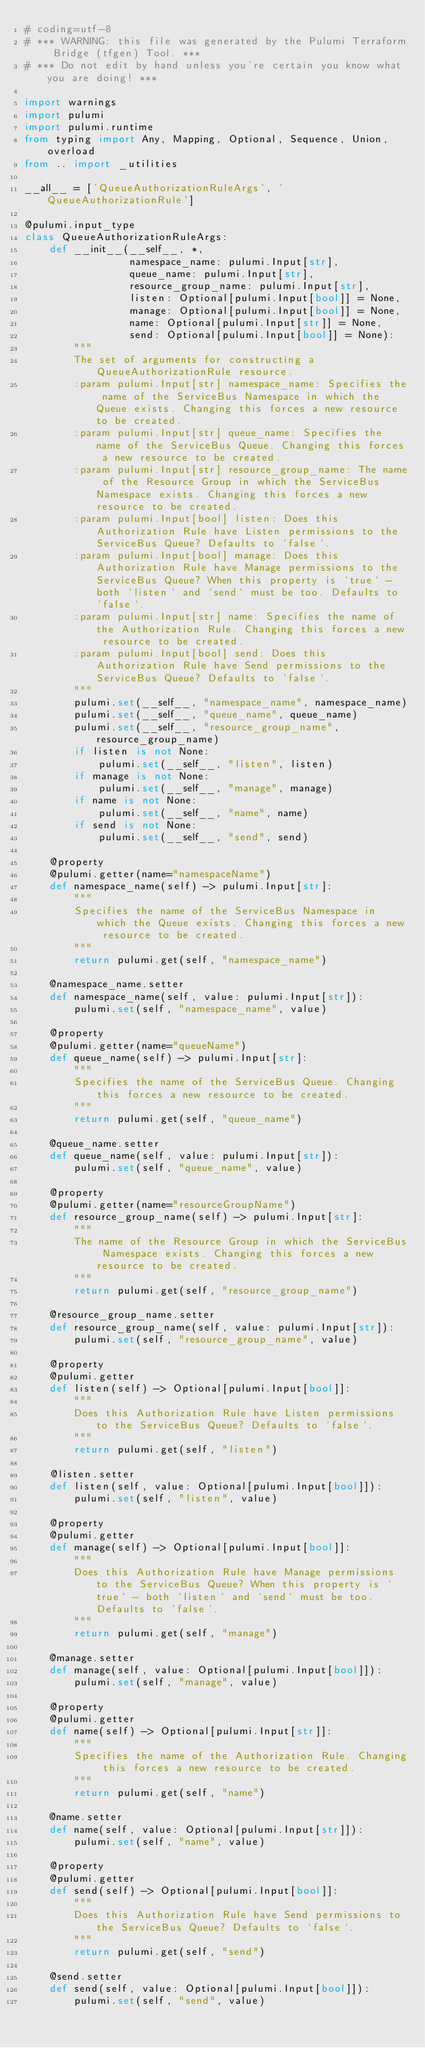Convert code to text. <code><loc_0><loc_0><loc_500><loc_500><_Python_># coding=utf-8
# *** WARNING: this file was generated by the Pulumi Terraform Bridge (tfgen) Tool. ***
# *** Do not edit by hand unless you're certain you know what you are doing! ***

import warnings
import pulumi
import pulumi.runtime
from typing import Any, Mapping, Optional, Sequence, Union, overload
from .. import _utilities

__all__ = ['QueueAuthorizationRuleArgs', 'QueueAuthorizationRule']

@pulumi.input_type
class QueueAuthorizationRuleArgs:
    def __init__(__self__, *,
                 namespace_name: pulumi.Input[str],
                 queue_name: pulumi.Input[str],
                 resource_group_name: pulumi.Input[str],
                 listen: Optional[pulumi.Input[bool]] = None,
                 manage: Optional[pulumi.Input[bool]] = None,
                 name: Optional[pulumi.Input[str]] = None,
                 send: Optional[pulumi.Input[bool]] = None):
        """
        The set of arguments for constructing a QueueAuthorizationRule resource.
        :param pulumi.Input[str] namespace_name: Specifies the name of the ServiceBus Namespace in which the Queue exists. Changing this forces a new resource to be created.
        :param pulumi.Input[str] queue_name: Specifies the name of the ServiceBus Queue. Changing this forces a new resource to be created.
        :param pulumi.Input[str] resource_group_name: The name of the Resource Group in which the ServiceBus Namespace exists. Changing this forces a new resource to be created.
        :param pulumi.Input[bool] listen: Does this Authorization Rule have Listen permissions to the ServiceBus Queue? Defaults to `false`.
        :param pulumi.Input[bool] manage: Does this Authorization Rule have Manage permissions to the ServiceBus Queue? When this property is `true` - both `listen` and `send` must be too. Defaults to `false`.
        :param pulumi.Input[str] name: Specifies the name of the Authorization Rule. Changing this forces a new resource to be created.
        :param pulumi.Input[bool] send: Does this Authorization Rule have Send permissions to the ServiceBus Queue? Defaults to `false`.
        """
        pulumi.set(__self__, "namespace_name", namespace_name)
        pulumi.set(__self__, "queue_name", queue_name)
        pulumi.set(__self__, "resource_group_name", resource_group_name)
        if listen is not None:
            pulumi.set(__self__, "listen", listen)
        if manage is not None:
            pulumi.set(__self__, "manage", manage)
        if name is not None:
            pulumi.set(__self__, "name", name)
        if send is not None:
            pulumi.set(__self__, "send", send)

    @property
    @pulumi.getter(name="namespaceName")
    def namespace_name(self) -> pulumi.Input[str]:
        """
        Specifies the name of the ServiceBus Namespace in which the Queue exists. Changing this forces a new resource to be created.
        """
        return pulumi.get(self, "namespace_name")

    @namespace_name.setter
    def namespace_name(self, value: pulumi.Input[str]):
        pulumi.set(self, "namespace_name", value)

    @property
    @pulumi.getter(name="queueName")
    def queue_name(self) -> pulumi.Input[str]:
        """
        Specifies the name of the ServiceBus Queue. Changing this forces a new resource to be created.
        """
        return pulumi.get(self, "queue_name")

    @queue_name.setter
    def queue_name(self, value: pulumi.Input[str]):
        pulumi.set(self, "queue_name", value)

    @property
    @pulumi.getter(name="resourceGroupName")
    def resource_group_name(self) -> pulumi.Input[str]:
        """
        The name of the Resource Group in which the ServiceBus Namespace exists. Changing this forces a new resource to be created.
        """
        return pulumi.get(self, "resource_group_name")

    @resource_group_name.setter
    def resource_group_name(self, value: pulumi.Input[str]):
        pulumi.set(self, "resource_group_name", value)

    @property
    @pulumi.getter
    def listen(self) -> Optional[pulumi.Input[bool]]:
        """
        Does this Authorization Rule have Listen permissions to the ServiceBus Queue? Defaults to `false`.
        """
        return pulumi.get(self, "listen")

    @listen.setter
    def listen(self, value: Optional[pulumi.Input[bool]]):
        pulumi.set(self, "listen", value)

    @property
    @pulumi.getter
    def manage(self) -> Optional[pulumi.Input[bool]]:
        """
        Does this Authorization Rule have Manage permissions to the ServiceBus Queue? When this property is `true` - both `listen` and `send` must be too. Defaults to `false`.
        """
        return pulumi.get(self, "manage")

    @manage.setter
    def manage(self, value: Optional[pulumi.Input[bool]]):
        pulumi.set(self, "manage", value)

    @property
    @pulumi.getter
    def name(self) -> Optional[pulumi.Input[str]]:
        """
        Specifies the name of the Authorization Rule. Changing this forces a new resource to be created.
        """
        return pulumi.get(self, "name")

    @name.setter
    def name(self, value: Optional[pulumi.Input[str]]):
        pulumi.set(self, "name", value)

    @property
    @pulumi.getter
    def send(self) -> Optional[pulumi.Input[bool]]:
        """
        Does this Authorization Rule have Send permissions to the ServiceBus Queue? Defaults to `false`.
        """
        return pulumi.get(self, "send")

    @send.setter
    def send(self, value: Optional[pulumi.Input[bool]]):
        pulumi.set(self, "send", value)

</code> 